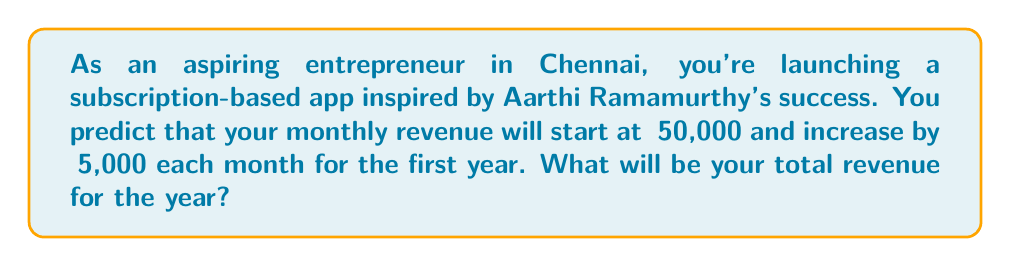Help me with this question. Let's approach this step-by-step using the arithmetic sequence sum formula:

1) First, identify the components of the arithmetic sequence:
   - First term, $a_1 = ₹50,000$
   - Common difference, $d = ₹5,000$
   - Number of terms, $n = 12$ (12 months in a year)

2) The formula for the sum of an arithmetic sequence is:

   $S_n = \frac{n}{2}(a_1 + a_n)$

   Where $a_n$ is the last term of the sequence.

3) Calculate $a_n$:
   $a_n = a_1 + (n-1)d$
   $a_n = 50,000 + (12-1)(5,000)$
   $a_n = 50,000 + 55,000 = ₹105,000$

4) Now, substitute into the sum formula:
   $S_{12} = \frac{12}{2}(50,000 + 105,000)$
   $S_{12} = 6(155,000)$
   $S_{12} = 930,000$

Therefore, the total revenue for the year will be ₹930,000.
Answer: ₹930,000 